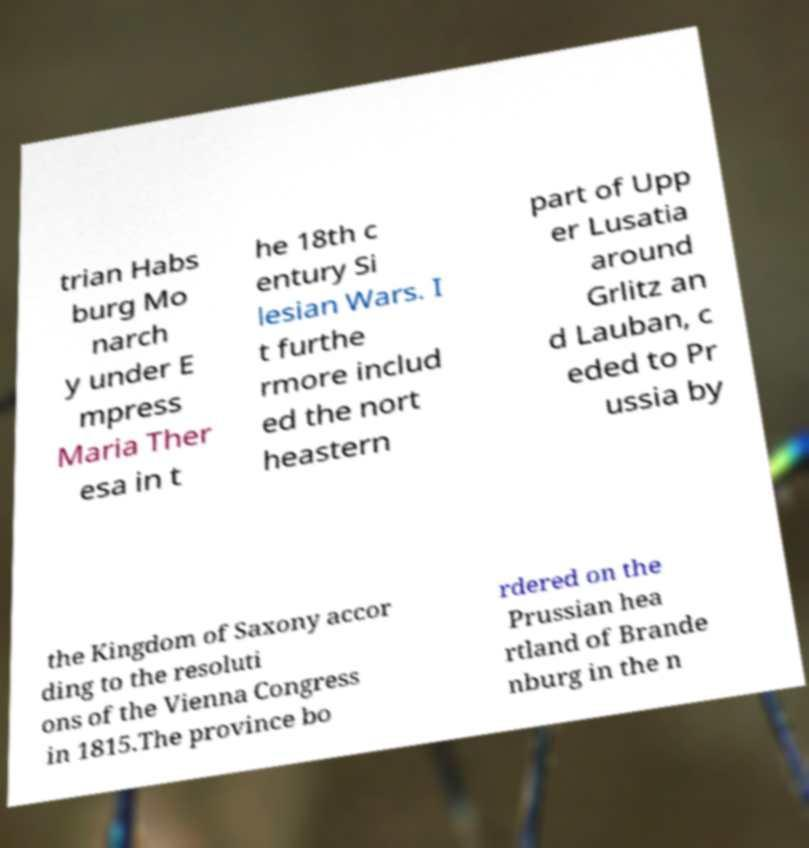Please identify and transcribe the text found in this image. trian Habs burg Mo narch y under E mpress Maria Ther esa in t he 18th c entury Si lesian Wars. I t furthe rmore includ ed the nort heastern part of Upp er Lusatia around Grlitz an d Lauban, c eded to Pr ussia by the Kingdom of Saxony accor ding to the resoluti ons of the Vienna Congress in 1815.The province bo rdered on the Prussian hea rtland of Brande nburg in the n 